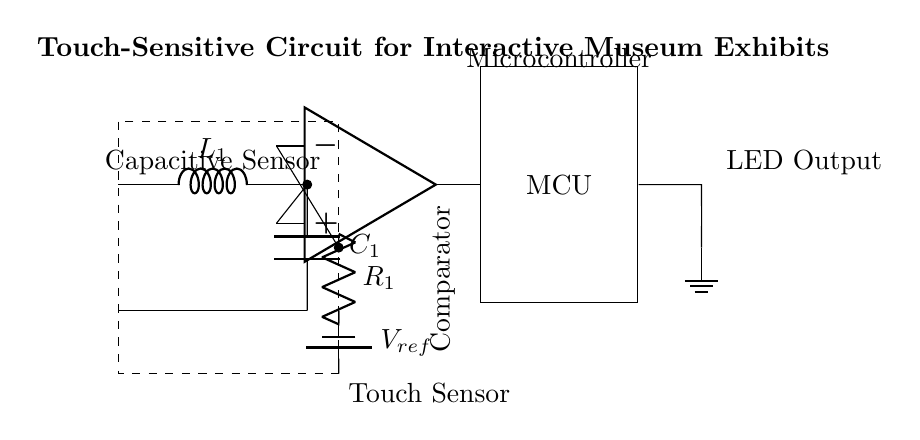What type of sensor is used in this circuit? The circuit utilizes a capacitive sensor, indicated by the labeled component in the diagram "Capacitive Sensor." This component detects touch based on capacitance changes.
Answer: capacitive sensor What is the role of the component labeled R1? R1 is a resistor that connects the output of the op-amp comparator to the negative terminal, ensuring a proper voltage reference for the comparator function. It plays a crucial role in the signal processing part of the circuit.
Answer: resistor What component is used to amplify the sensor's signal? The op-amp, or operational amplifier, serves to amplify the output signal from the capacitive sensor in coordination with the voltage reference. Thus, it enables the circuit to react appropriately to touch events.
Answer: op-amp What does the LED in this circuit indicate? The LED serves as an output indicator, showing the operational status or the result of the touch detected by the capacitive sensor, specifically if the touch has been recognized and processed.
Answer: operational status What is the function of the microcontroller in this circuit? The microcontroller (MCU) processes the signals received from the op-amp and controls the LED based on whether a touch is detected, making it the central processing unit of the circuit.
Answer: signal processing What type of current flows through the LED? The LED receives direct current, indicated by the circuit layout where the output connects to it and then to the ground, allowing the LED to light up when activated by the microcontroller's output.
Answer: direct current 